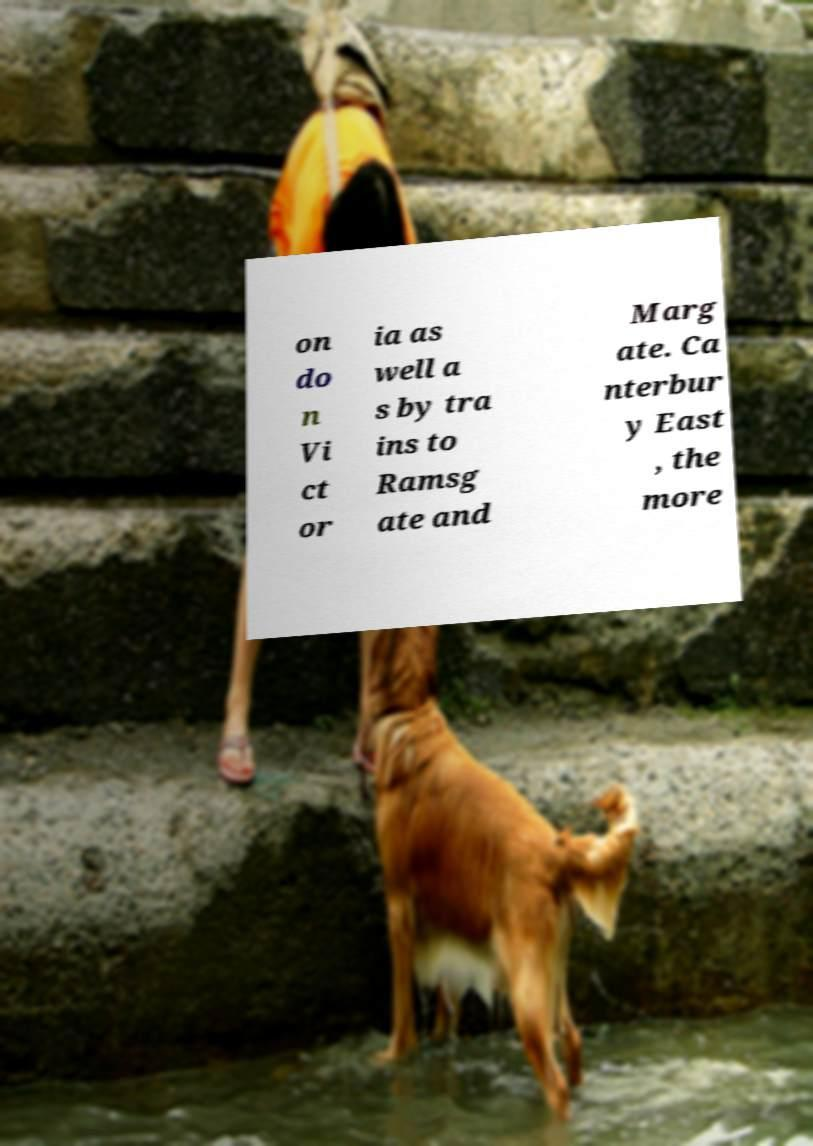I need the written content from this picture converted into text. Can you do that? on do n Vi ct or ia as well a s by tra ins to Ramsg ate and Marg ate. Ca nterbur y East , the more 